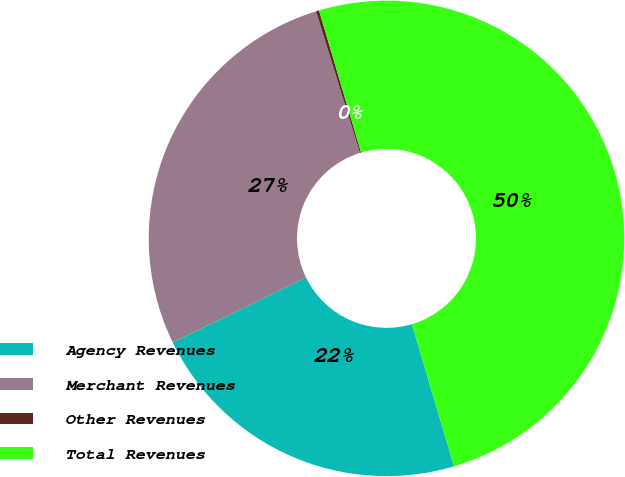Convert chart to OTSL. <chart><loc_0><loc_0><loc_500><loc_500><pie_chart><fcel>Agency Revenues<fcel>Merchant Revenues<fcel>Other Revenues<fcel>Total Revenues<nl><fcel>22.38%<fcel>27.42%<fcel>0.21%<fcel>50.0%<nl></chart> 